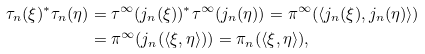<formula> <loc_0><loc_0><loc_500><loc_500>\tau _ { n } ( \xi ) ^ { * } \tau _ { n } ( \eta ) & = \tau ^ { \infty } ( j _ { n } ( \xi ) ) ^ { * } \tau ^ { \infty } ( j _ { n } ( \eta ) ) = \pi ^ { \infty } ( \langle j _ { n } ( \xi ) , j _ { n } ( \eta ) \rangle ) \\ & = \pi ^ { \infty } ( j _ { n } ( \langle \xi , \eta \rangle ) ) = \pi _ { n } ( \langle \xi , \eta \rangle ) ,</formula> 